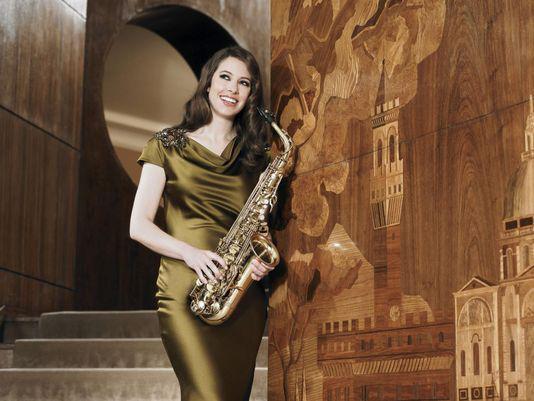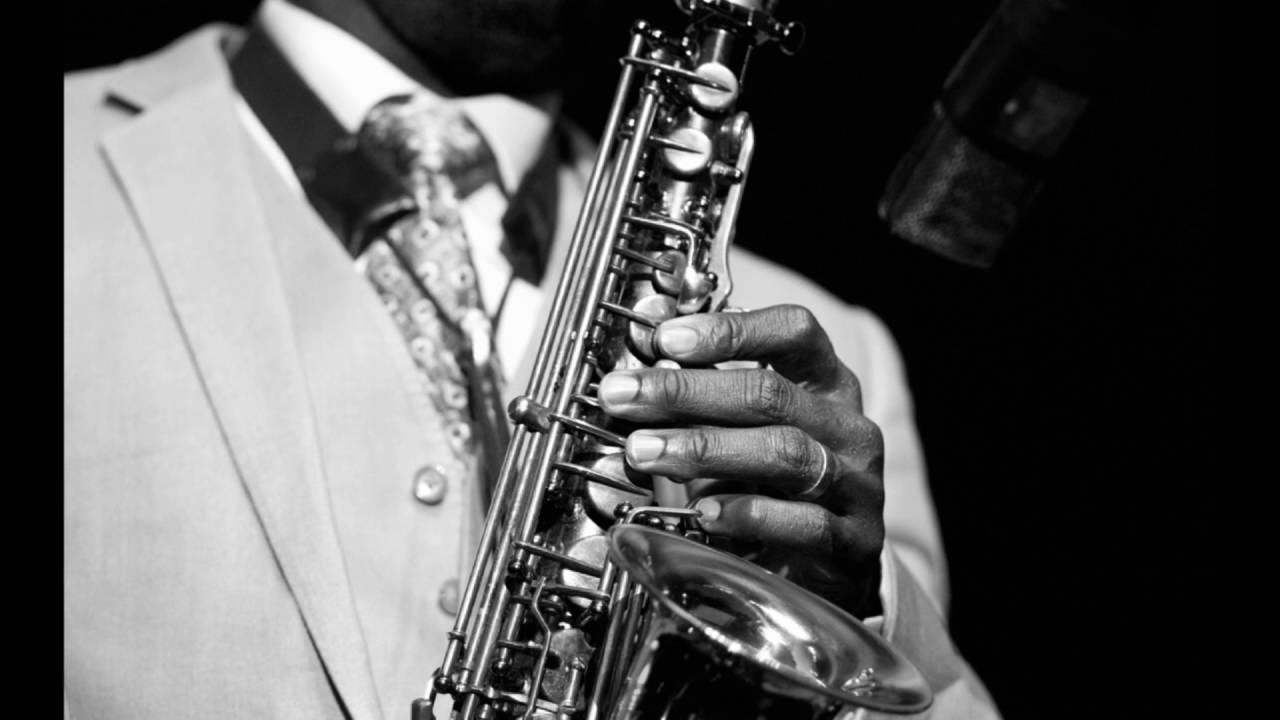The first image is the image on the left, the second image is the image on the right. Assess this claim about the two images: "One image shows a saxophone held by a dark-skinned man in a suit, and the other image shows someone with long hair holding a saxophone in front of a flight of stairs.". Correct or not? Answer yes or no. Yes. The first image is the image on the left, the second image is the image on the right. Examine the images to the left and right. Is the description "Every single person's elbow is clothed." accurate? Answer yes or no. No. 